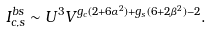<formula> <loc_0><loc_0><loc_500><loc_500>I ^ { b s } _ { c , s } \sim U ^ { 3 } V ^ { g _ { c } ( 2 + 6 \alpha ^ { 2 } ) + g _ { s } ( 6 + 2 \beta ^ { 2 } ) - 2 } .</formula> 